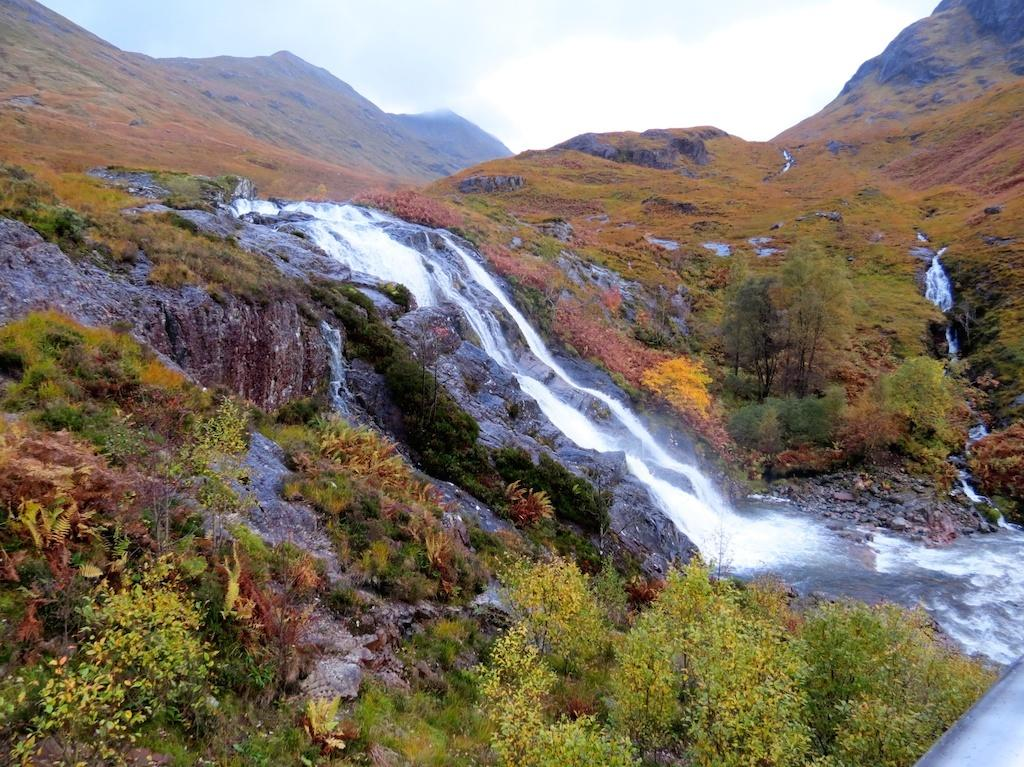What type of landscape can be seen in the image? There are hills in the image. What natural feature is visible besides the hills? There is water visible in the image. What type of vegetation is present in the image? There are plants in the image. What is visible in the background of the image? The sky is visible in the image. How many tails can be seen on the brothers in the image? There are no brothers or tails present in the image. 